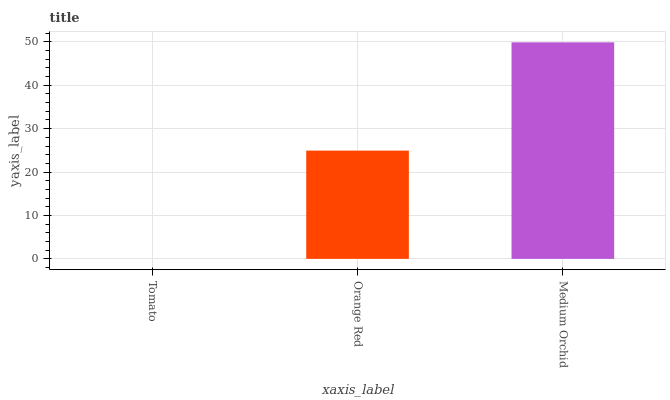Is Orange Red the minimum?
Answer yes or no. No. Is Orange Red the maximum?
Answer yes or no. No. Is Orange Red greater than Tomato?
Answer yes or no. Yes. Is Tomato less than Orange Red?
Answer yes or no. Yes. Is Tomato greater than Orange Red?
Answer yes or no. No. Is Orange Red less than Tomato?
Answer yes or no. No. Is Orange Red the high median?
Answer yes or no. Yes. Is Orange Red the low median?
Answer yes or no. Yes. Is Tomato the high median?
Answer yes or no. No. Is Tomato the low median?
Answer yes or no. No. 